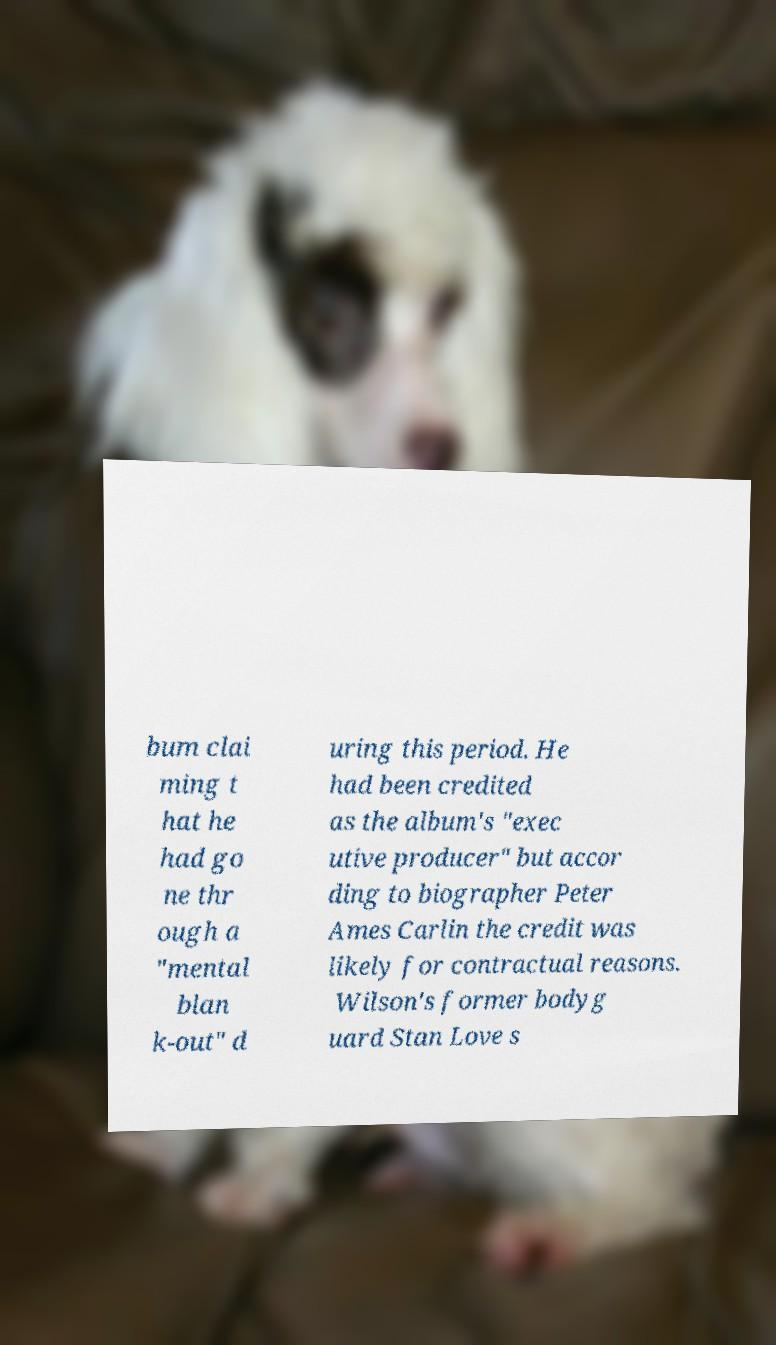Please identify and transcribe the text found in this image. bum clai ming t hat he had go ne thr ough a "mental blan k-out" d uring this period. He had been credited as the album's "exec utive producer" but accor ding to biographer Peter Ames Carlin the credit was likely for contractual reasons. Wilson's former bodyg uard Stan Love s 